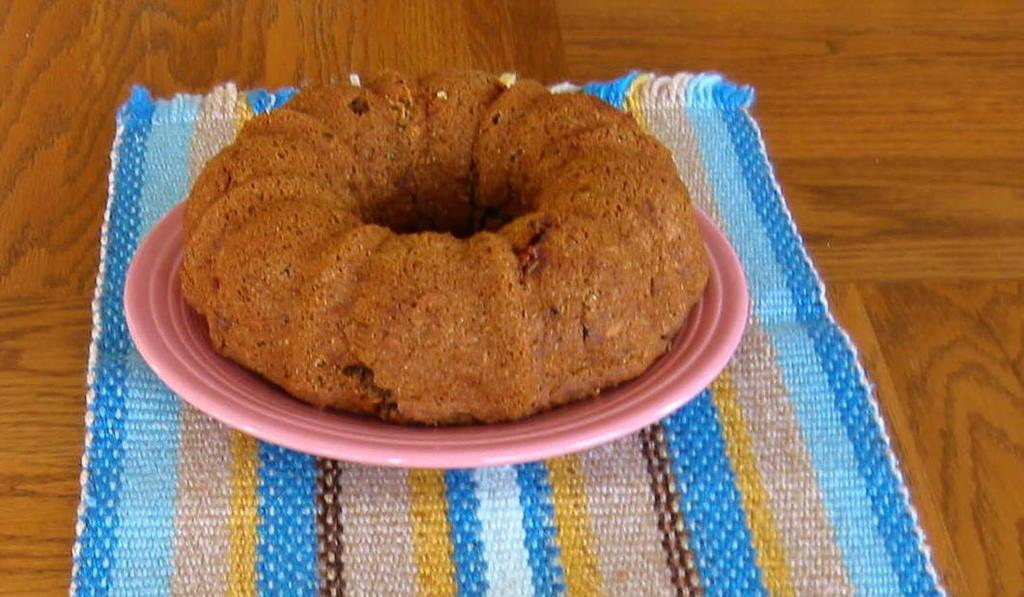What is the main subject of the image? The main subject of the image is food. How is the food presented in the image? The food is on a pink-colored plate. What else can be seen in the image besides the food and plate? There is a cloth of different colors in the image. What message is written on the mother's locket in the image? There is no mother or locket present in the image; it features food on a pink-colored plate and a cloth of different colors. 